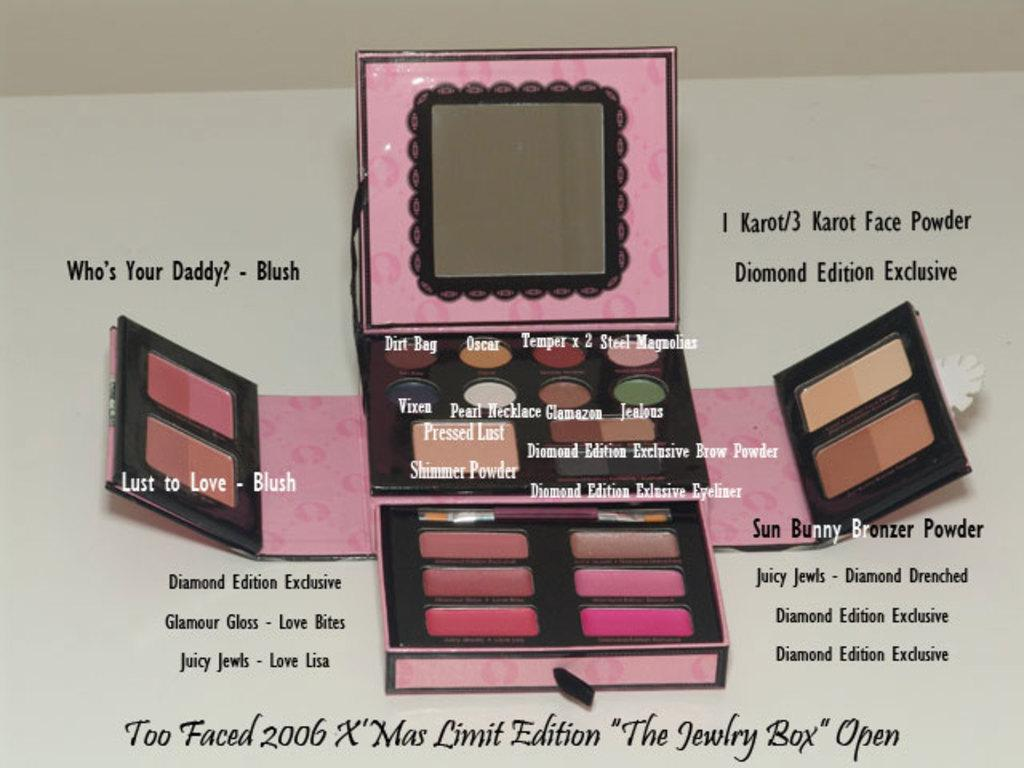<image>
Present a compact description of the photo's key features. Too Faced 2006 X Mas limited edition makeup kit, detailing what each item is. 